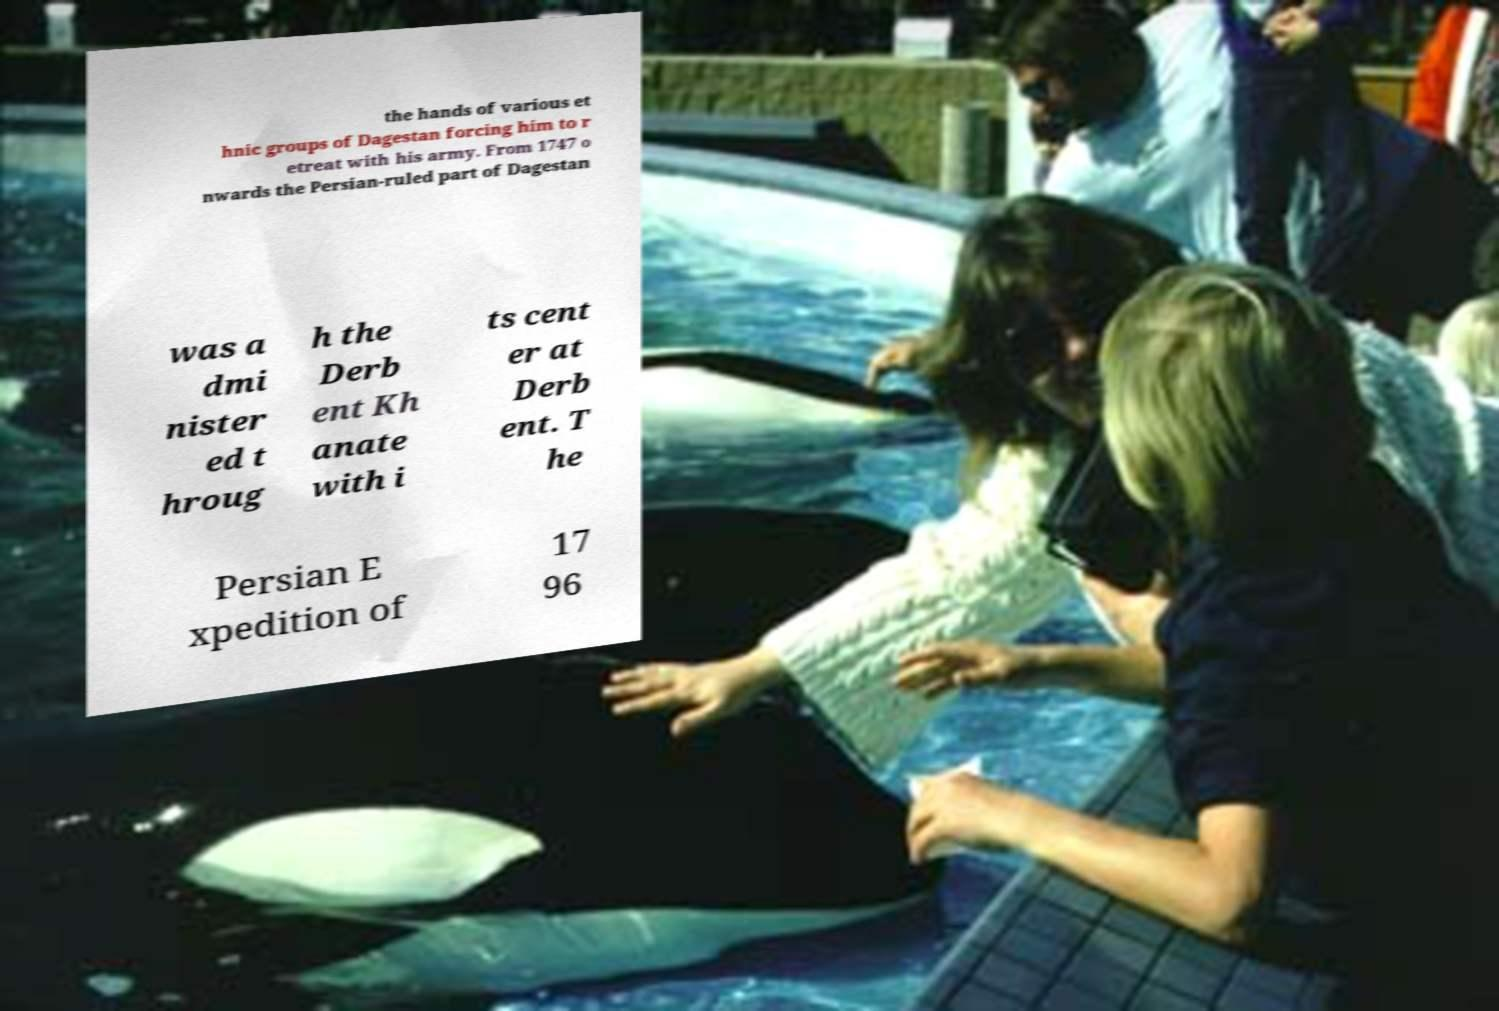There's text embedded in this image that I need extracted. Can you transcribe it verbatim? the hands of various et hnic groups of Dagestan forcing him to r etreat with his army. From 1747 o nwards the Persian-ruled part of Dagestan was a dmi nister ed t hroug h the Derb ent Kh anate with i ts cent er at Derb ent. T he Persian E xpedition of 17 96 